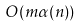<formula> <loc_0><loc_0><loc_500><loc_500>O ( m \alpha ( n ) )</formula> 